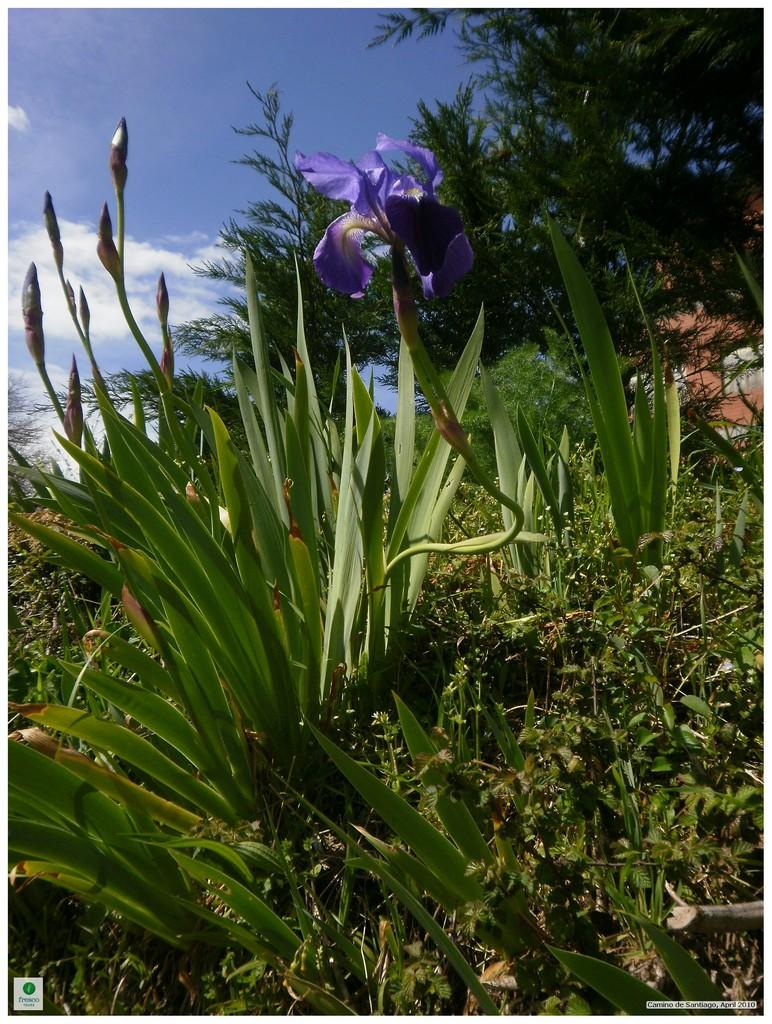What type of flower is in the image? There is a purple flower in the image. What other types of plants are in the image? There are green plants in the image. What else can be seen in the image besides plants? There are trees in the image. What is visible in the background of the image? Clouds and the sky are visible in the background of the image. Where are the scissors located in the image? There are no scissors present in the image. What color is the fifth flower in the image? There is no mention of a fifth flower in the image, as only one flower is described. 